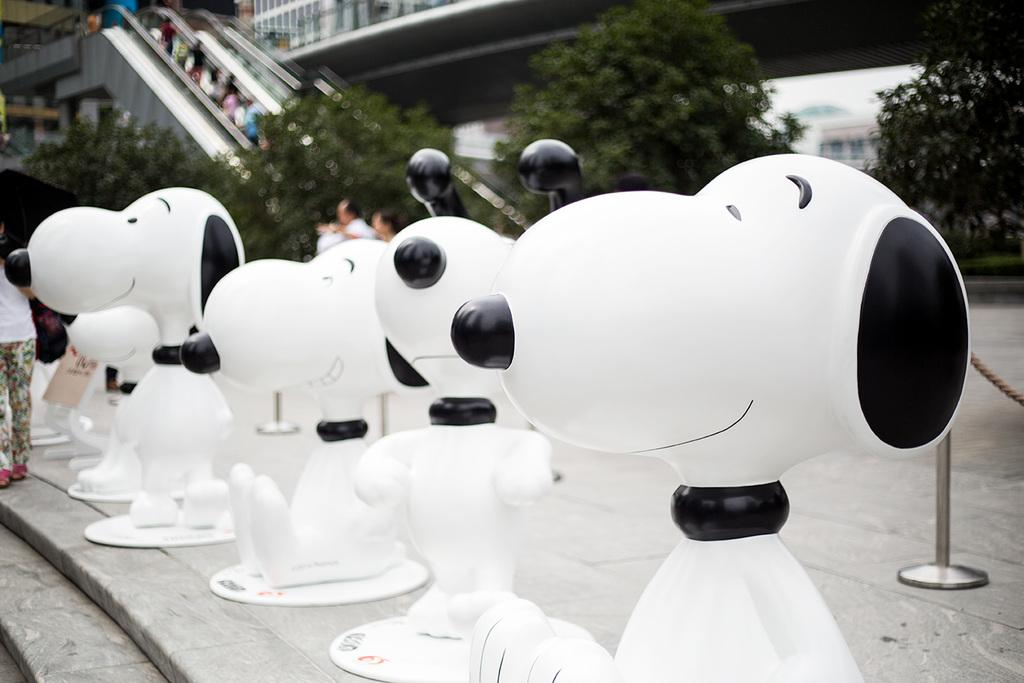What type of statues can be seen in the image? There are statues of dogs in the image. What architectural feature is present at the bottom of the image? There are steps at the bottom of the image. What can be seen in the background of the image? Trees and escalators are visible in the background of the image. Is there a person present in the image? Yes, there is a person on the left side of the image. What advice does the person on the left side of the image give to the dogs in the image? There is no indication in the image that the person is giving advice to the dogs, as the person and dogs are represented by statues. 